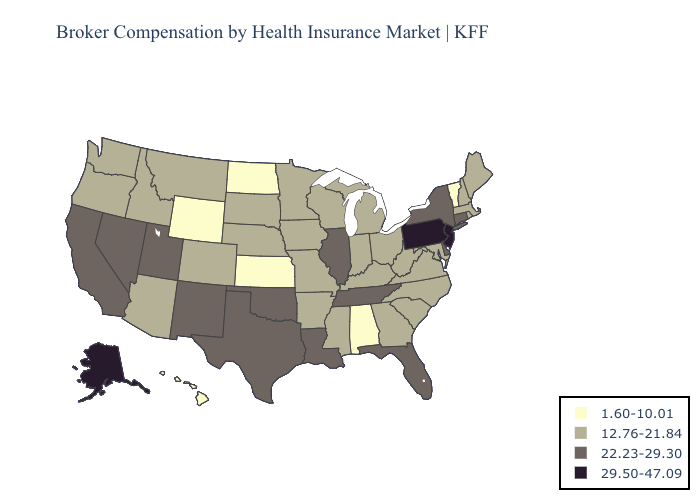Which states hav the highest value in the South?
Keep it brief. Delaware, Florida, Louisiana, Oklahoma, Tennessee, Texas. Name the states that have a value in the range 22.23-29.30?
Keep it brief. California, Connecticut, Delaware, Florida, Illinois, Louisiana, Nevada, New Mexico, New York, Oklahoma, Tennessee, Texas, Utah. Does Pennsylvania have the lowest value in the Northeast?
Keep it brief. No. Does Illinois have the highest value in the MidWest?
Concise answer only. Yes. Is the legend a continuous bar?
Write a very short answer. No. What is the value of Virginia?
Concise answer only. 12.76-21.84. Does Tennessee have a lower value than Minnesota?
Quick response, please. No. Among the states that border Kansas , which have the highest value?
Answer briefly. Oklahoma. Name the states that have a value in the range 12.76-21.84?
Write a very short answer. Arizona, Arkansas, Colorado, Georgia, Idaho, Indiana, Iowa, Kentucky, Maine, Maryland, Massachusetts, Michigan, Minnesota, Mississippi, Missouri, Montana, Nebraska, New Hampshire, North Carolina, Ohio, Oregon, Rhode Island, South Carolina, South Dakota, Virginia, Washington, West Virginia, Wisconsin. What is the highest value in the MidWest ?
Quick response, please. 22.23-29.30. Does Georgia have the lowest value in the USA?
Give a very brief answer. No. Which states have the highest value in the USA?
Short answer required. Alaska, New Jersey, Pennsylvania. What is the value of Maryland?
Keep it brief. 12.76-21.84. Among the states that border Indiana , which have the highest value?
Write a very short answer. Illinois. What is the lowest value in the USA?
Concise answer only. 1.60-10.01. 